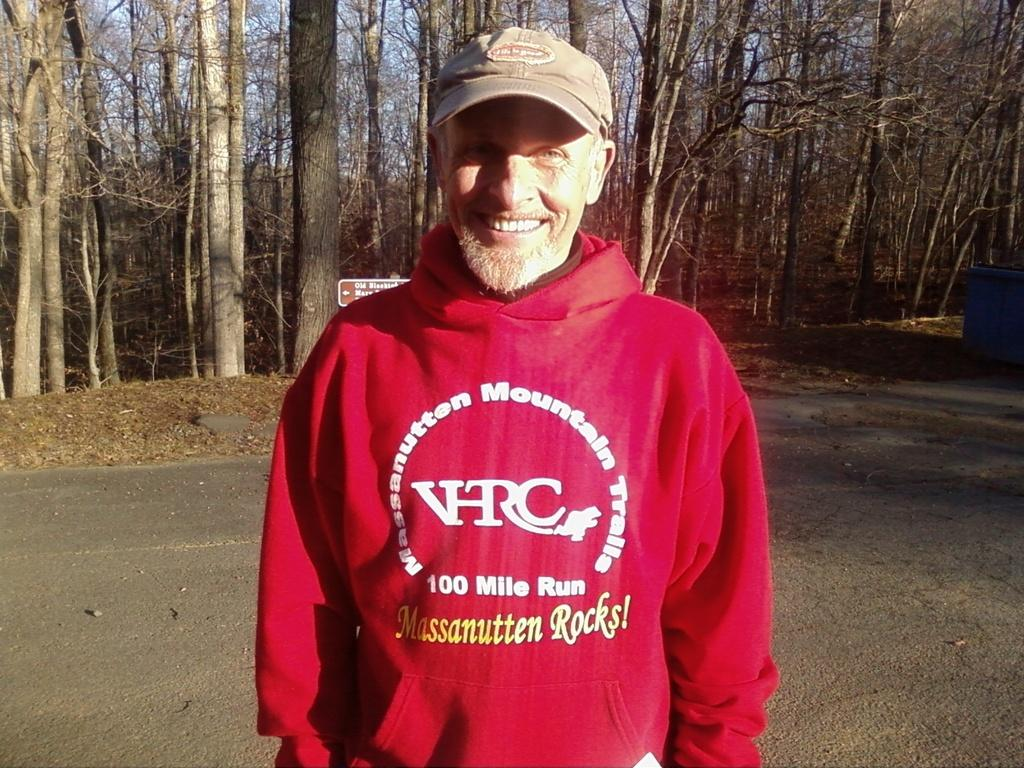<image>
Relay a brief, clear account of the picture shown. A man in a baseball hat is wearing a red sweatshirt from a 100 mile run. 